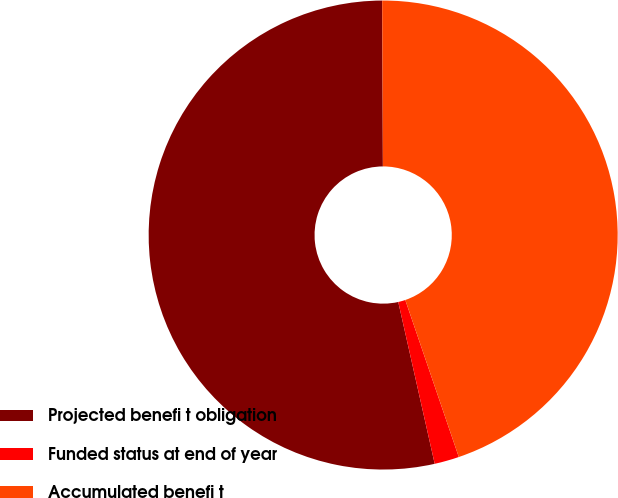Convert chart to OTSL. <chart><loc_0><loc_0><loc_500><loc_500><pie_chart><fcel>Projected benefi t obligation<fcel>Funded status at end of year<fcel>Accumulated benefi t<nl><fcel>53.46%<fcel>1.7%<fcel>44.84%<nl></chart> 